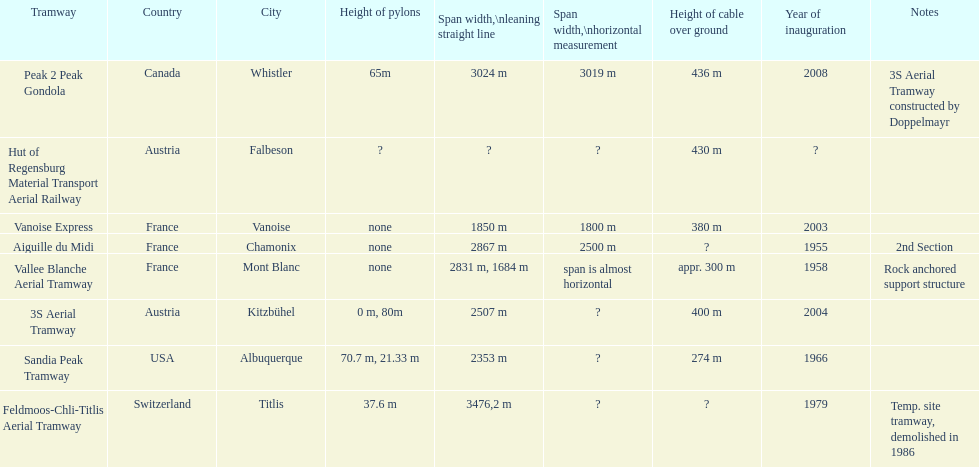Was the inauguration of the peak 2 peak gondola earlier than that of the vanoise express? No. 